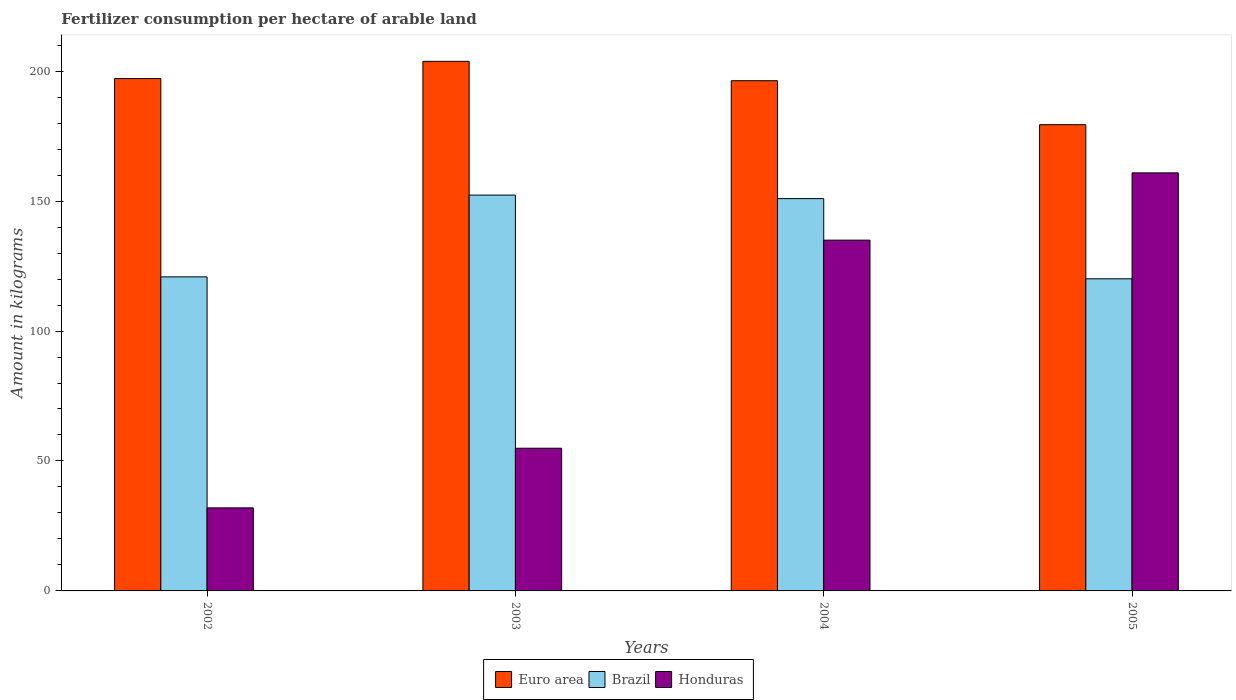How many different coloured bars are there?
Make the answer very short. 3. Are the number of bars per tick equal to the number of legend labels?
Provide a succinct answer. Yes. Are the number of bars on each tick of the X-axis equal?
Provide a short and direct response. Yes. What is the label of the 4th group of bars from the left?
Offer a very short reply. 2005. In how many cases, is the number of bars for a given year not equal to the number of legend labels?
Your response must be concise. 0. What is the amount of fertilizer consumption in Euro area in 2003?
Give a very brief answer. 203.76. Across all years, what is the maximum amount of fertilizer consumption in Brazil?
Your answer should be compact. 152.31. Across all years, what is the minimum amount of fertilizer consumption in Honduras?
Your answer should be compact. 31.96. In which year was the amount of fertilizer consumption in Honduras maximum?
Offer a terse response. 2005. What is the total amount of fertilizer consumption in Euro area in the graph?
Your answer should be very brief. 776.62. What is the difference between the amount of fertilizer consumption in Honduras in 2003 and that in 2004?
Your response must be concise. -80.07. What is the difference between the amount of fertilizer consumption in Honduras in 2005 and the amount of fertilizer consumption in Brazil in 2002?
Give a very brief answer. 40.01. What is the average amount of fertilizer consumption in Honduras per year?
Ensure brevity in your answer.  95.67. In the year 2003, what is the difference between the amount of fertilizer consumption in Brazil and amount of fertilizer consumption in Honduras?
Make the answer very short. 97.41. In how many years, is the amount of fertilizer consumption in Brazil greater than 20 kg?
Ensure brevity in your answer.  4. What is the ratio of the amount of fertilizer consumption in Euro area in 2003 to that in 2005?
Offer a very short reply. 1.14. Is the difference between the amount of fertilizer consumption in Brazil in 2003 and 2004 greater than the difference between the amount of fertilizer consumption in Honduras in 2003 and 2004?
Ensure brevity in your answer.  Yes. What is the difference between the highest and the second highest amount of fertilizer consumption in Euro area?
Keep it short and to the point. 6.61. What is the difference between the highest and the lowest amount of fertilizer consumption in Honduras?
Offer a very short reply. 128.89. In how many years, is the amount of fertilizer consumption in Brazil greater than the average amount of fertilizer consumption in Brazil taken over all years?
Give a very brief answer. 2. What does the 2nd bar from the left in 2005 represents?
Offer a very short reply. Brazil. What does the 2nd bar from the right in 2005 represents?
Provide a succinct answer. Brazil. How many bars are there?
Ensure brevity in your answer.  12. Are all the bars in the graph horizontal?
Make the answer very short. No. How many years are there in the graph?
Give a very brief answer. 4. Where does the legend appear in the graph?
Offer a very short reply. Bottom center. What is the title of the graph?
Your answer should be very brief. Fertilizer consumption per hectare of arable land. What is the label or title of the X-axis?
Provide a short and direct response. Years. What is the label or title of the Y-axis?
Offer a very short reply. Amount in kilograms. What is the Amount in kilograms in Euro area in 2002?
Keep it short and to the point. 197.15. What is the Amount in kilograms of Brazil in 2002?
Provide a short and direct response. 120.84. What is the Amount in kilograms of Honduras in 2002?
Your response must be concise. 31.96. What is the Amount in kilograms of Euro area in 2003?
Offer a very short reply. 203.76. What is the Amount in kilograms of Brazil in 2003?
Ensure brevity in your answer.  152.31. What is the Amount in kilograms of Honduras in 2003?
Offer a very short reply. 54.9. What is the Amount in kilograms in Euro area in 2004?
Provide a succinct answer. 196.31. What is the Amount in kilograms in Brazil in 2004?
Make the answer very short. 150.95. What is the Amount in kilograms of Honduras in 2004?
Make the answer very short. 134.97. What is the Amount in kilograms in Euro area in 2005?
Offer a terse response. 179.4. What is the Amount in kilograms in Brazil in 2005?
Keep it short and to the point. 120.1. What is the Amount in kilograms of Honduras in 2005?
Give a very brief answer. 160.85. Across all years, what is the maximum Amount in kilograms in Euro area?
Your answer should be very brief. 203.76. Across all years, what is the maximum Amount in kilograms of Brazil?
Give a very brief answer. 152.31. Across all years, what is the maximum Amount in kilograms of Honduras?
Offer a very short reply. 160.85. Across all years, what is the minimum Amount in kilograms in Euro area?
Offer a terse response. 179.4. Across all years, what is the minimum Amount in kilograms in Brazil?
Your response must be concise. 120.1. Across all years, what is the minimum Amount in kilograms of Honduras?
Provide a short and direct response. 31.96. What is the total Amount in kilograms of Euro area in the graph?
Your response must be concise. 776.62. What is the total Amount in kilograms in Brazil in the graph?
Make the answer very short. 544.19. What is the total Amount in kilograms in Honduras in the graph?
Offer a very short reply. 382.67. What is the difference between the Amount in kilograms in Euro area in 2002 and that in 2003?
Make the answer very short. -6.61. What is the difference between the Amount in kilograms of Brazil in 2002 and that in 2003?
Give a very brief answer. -31.46. What is the difference between the Amount in kilograms of Honduras in 2002 and that in 2003?
Make the answer very short. -22.94. What is the difference between the Amount in kilograms of Euro area in 2002 and that in 2004?
Ensure brevity in your answer.  0.84. What is the difference between the Amount in kilograms of Brazil in 2002 and that in 2004?
Your answer should be compact. -30.11. What is the difference between the Amount in kilograms in Honduras in 2002 and that in 2004?
Give a very brief answer. -103.01. What is the difference between the Amount in kilograms of Euro area in 2002 and that in 2005?
Offer a very short reply. 17.75. What is the difference between the Amount in kilograms in Brazil in 2002 and that in 2005?
Keep it short and to the point. 0.74. What is the difference between the Amount in kilograms in Honduras in 2002 and that in 2005?
Make the answer very short. -128.89. What is the difference between the Amount in kilograms in Euro area in 2003 and that in 2004?
Provide a short and direct response. 7.45. What is the difference between the Amount in kilograms in Brazil in 2003 and that in 2004?
Offer a very short reply. 1.36. What is the difference between the Amount in kilograms of Honduras in 2003 and that in 2004?
Your response must be concise. -80.07. What is the difference between the Amount in kilograms of Euro area in 2003 and that in 2005?
Make the answer very short. 24.37. What is the difference between the Amount in kilograms of Brazil in 2003 and that in 2005?
Keep it short and to the point. 32.2. What is the difference between the Amount in kilograms of Honduras in 2003 and that in 2005?
Give a very brief answer. -105.95. What is the difference between the Amount in kilograms in Euro area in 2004 and that in 2005?
Give a very brief answer. 16.92. What is the difference between the Amount in kilograms in Brazil in 2004 and that in 2005?
Give a very brief answer. 30.85. What is the difference between the Amount in kilograms in Honduras in 2004 and that in 2005?
Keep it short and to the point. -25.88. What is the difference between the Amount in kilograms in Euro area in 2002 and the Amount in kilograms in Brazil in 2003?
Provide a succinct answer. 44.85. What is the difference between the Amount in kilograms in Euro area in 2002 and the Amount in kilograms in Honduras in 2003?
Offer a terse response. 142.25. What is the difference between the Amount in kilograms of Brazil in 2002 and the Amount in kilograms of Honduras in 2003?
Give a very brief answer. 65.94. What is the difference between the Amount in kilograms of Euro area in 2002 and the Amount in kilograms of Brazil in 2004?
Offer a terse response. 46.2. What is the difference between the Amount in kilograms in Euro area in 2002 and the Amount in kilograms in Honduras in 2004?
Keep it short and to the point. 62.18. What is the difference between the Amount in kilograms of Brazil in 2002 and the Amount in kilograms of Honduras in 2004?
Give a very brief answer. -14.13. What is the difference between the Amount in kilograms in Euro area in 2002 and the Amount in kilograms in Brazil in 2005?
Provide a succinct answer. 77.05. What is the difference between the Amount in kilograms of Euro area in 2002 and the Amount in kilograms of Honduras in 2005?
Make the answer very short. 36.3. What is the difference between the Amount in kilograms of Brazil in 2002 and the Amount in kilograms of Honduras in 2005?
Keep it short and to the point. -40.01. What is the difference between the Amount in kilograms of Euro area in 2003 and the Amount in kilograms of Brazil in 2004?
Provide a short and direct response. 52.82. What is the difference between the Amount in kilograms of Euro area in 2003 and the Amount in kilograms of Honduras in 2004?
Give a very brief answer. 68.79. What is the difference between the Amount in kilograms in Brazil in 2003 and the Amount in kilograms in Honduras in 2004?
Make the answer very short. 17.34. What is the difference between the Amount in kilograms of Euro area in 2003 and the Amount in kilograms of Brazil in 2005?
Provide a succinct answer. 83.66. What is the difference between the Amount in kilograms in Euro area in 2003 and the Amount in kilograms in Honduras in 2005?
Provide a succinct answer. 42.91. What is the difference between the Amount in kilograms in Brazil in 2003 and the Amount in kilograms in Honduras in 2005?
Your answer should be very brief. -8.55. What is the difference between the Amount in kilograms of Euro area in 2004 and the Amount in kilograms of Brazil in 2005?
Offer a terse response. 76.21. What is the difference between the Amount in kilograms in Euro area in 2004 and the Amount in kilograms in Honduras in 2005?
Keep it short and to the point. 35.46. What is the difference between the Amount in kilograms of Brazil in 2004 and the Amount in kilograms of Honduras in 2005?
Provide a short and direct response. -9.91. What is the average Amount in kilograms in Euro area per year?
Offer a very short reply. 194.15. What is the average Amount in kilograms in Brazil per year?
Your answer should be compact. 136.05. What is the average Amount in kilograms in Honduras per year?
Ensure brevity in your answer.  95.67. In the year 2002, what is the difference between the Amount in kilograms in Euro area and Amount in kilograms in Brazil?
Make the answer very short. 76.31. In the year 2002, what is the difference between the Amount in kilograms of Euro area and Amount in kilograms of Honduras?
Provide a succinct answer. 165.19. In the year 2002, what is the difference between the Amount in kilograms of Brazil and Amount in kilograms of Honduras?
Offer a terse response. 88.88. In the year 2003, what is the difference between the Amount in kilograms of Euro area and Amount in kilograms of Brazil?
Provide a succinct answer. 51.46. In the year 2003, what is the difference between the Amount in kilograms in Euro area and Amount in kilograms in Honduras?
Provide a succinct answer. 148.86. In the year 2003, what is the difference between the Amount in kilograms of Brazil and Amount in kilograms of Honduras?
Offer a terse response. 97.41. In the year 2004, what is the difference between the Amount in kilograms of Euro area and Amount in kilograms of Brazil?
Your answer should be very brief. 45.37. In the year 2004, what is the difference between the Amount in kilograms in Euro area and Amount in kilograms in Honduras?
Your answer should be compact. 61.35. In the year 2004, what is the difference between the Amount in kilograms in Brazil and Amount in kilograms in Honduras?
Keep it short and to the point. 15.98. In the year 2005, what is the difference between the Amount in kilograms of Euro area and Amount in kilograms of Brazil?
Provide a short and direct response. 59.3. In the year 2005, what is the difference between the Amount in kilograms of Euro area and Amount in kilograms of Honduras?
Ensure brevity in your answer.  18.54. In the year 2005, what is the difference between the Amount in kilograms of Brazil and Amount in kilograms of Honduras?
Provide a short and direct response. -40.75. What is the ratio of the Amount in kilograms of Euro area in 2002 to that in 2003?
Your answer should be very brief. 0.97. What is the ratio of the Amount in kilograms in Brazil in 2002 to that in 2003?
Offer a very short reply. 0.79. What is the ratio of the Amount in kilograms of Honduras in 2002 to that in 2003?
Provide a short and direct response. 0.58. What is the ratio of the Amount in kilograms of Euro area in 2002 to that in 2004?
Ensure brevity in your answer.  1. What is the ratio of the Amount in kilograms of Brazil in 2002 to that in 2004?
Offer a terse response. 0.8. What is the ratio of the Amount in kilograms of Honduras in 2002 to that in 2004?
Make the answer very short. 0.24. What is the ratio of the Amount in kilograms in Euro area in 2002 to that in 2005?
Your response must be concise. 1.1. What is the ratio of the Amount in kilograms in Brazil in 2002 to that in 2005?
Make the answer very short. 1.01. What is the ratio of the Amount in kilograms in Honduras in 2002 to that in 2005?
Your answer should be compact. 0.2. What is the ratio of the Amount in kilograms in Euro area in 2003 to that in 2004?
Give a very brief answer. 1.04. What is the ratio of the Amount in kilograms of Honduras in 2003 to that in 2004?
Keep it short and to the point. 0.41. What is the ratio of the Amount in kilograms in Euro area in 2003 to that in 2005?
Offer a very short reply. 1.14. What is the ratio of the Amount in kilograms in Brazil in 2003 to that in 2005?
Make the answer very short. 1.27. What is the ratio of the Amount in kilograms of Honduras in 2003 to that in 2005?
Ensure brevity in your answer.  0.34. What is the ratio of the Amount in kilograms of Euro area in 2004 to that in 2005?
Your response must be concise. 1.09. What is the ratio of the Amount in kilograms of Brazil in 2004 to that in 2005?
Your answer should be compact. 1.26. What is the ratio of the Amount in kilograms in Honduras in 2004 to that in 2005?
Provide a short and direct response. 0.84. What is the difference between the highest and the second highest Amount in kilograms in Euro area?
Provide a short and direct response. 6.61. What is the difference between the highest and the second highest Amount in kilograms in Brazil?
Ensure brevity in your answer.  1.36. What is the difference between the highest and the second highest Amount in kilograms in Honduras?
Provide a short and direct response. 25.88. What is the difference between the highest and the lowest Amount in kilograms in Euro area?
Your response must be concise. 24.37. What is the difference between the highest and the lowest Amount in kilograms of Brazil?
Ensure brevity in your answer.  32.2. What is the difference between the highest and the lowest Amount in kilograms in Honduras?
Your response must be concise. 128.89. 